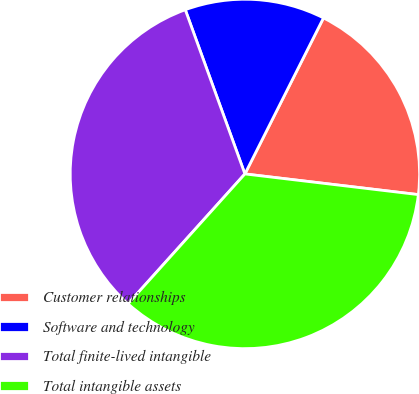<chart> <loc_0><loc_0><loc_500><loc_500><pie_chart><fcel>Customer relationships<fcel>Software and technology<fcel>Total finite-lived intangible<fcel>Total intangible assets<nl><fcel>19.46%<fcel>12.97%<fcel>32.79%<fcel>34.77%<nl></chart> 